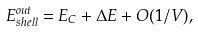Convert formula to latex. <formula><loc_0><loc_0><loc_500><loc_500>E ^ { o u t } _ { s h e l l } = E _ { C } + \Delta E + O ( 1 / V ) ,</formula> 